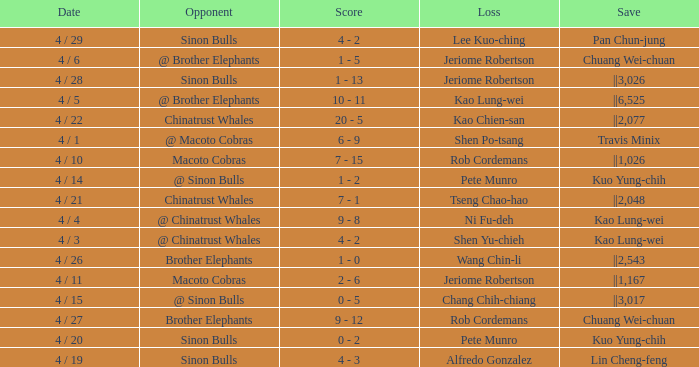Who earned the save in the game against the Sinon Bulls when Jeriome Robertson took the loss? ||3,026. 